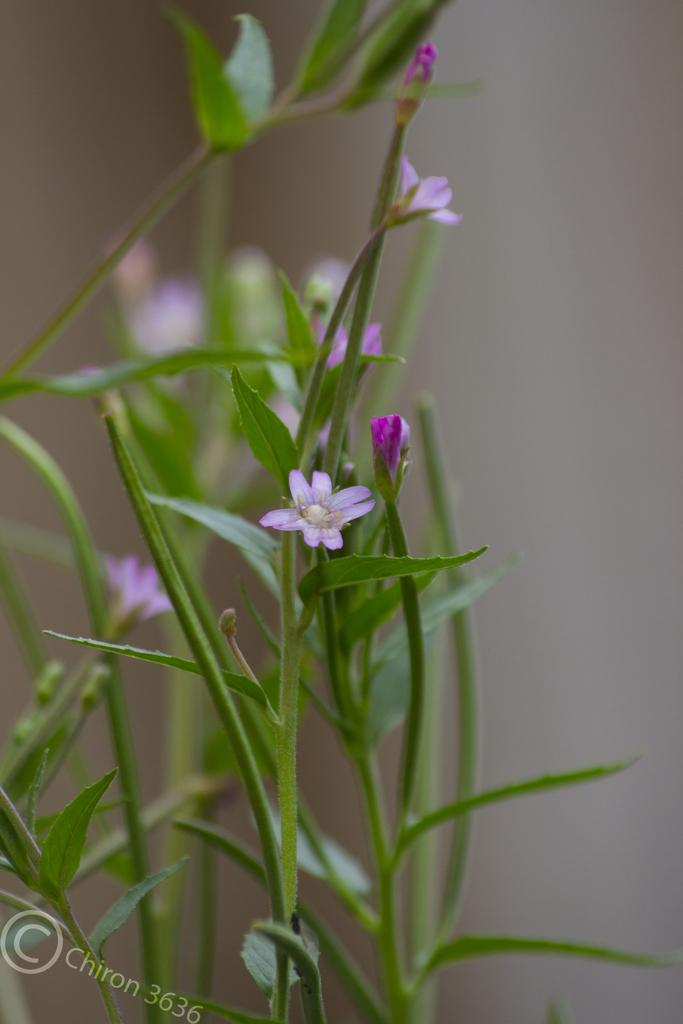What types of living organisms can be seen in the image? The image contains plants and flowers. Can you describe the background of the image? The background of the image is blurred. What color is the crayon used to draw the flowers in the image? There is no crayon present in the image, as the flowers are real and not drawn. How many steps does it take to reach the flowers in the image? There is no indication of distance or location in the image, so it is not possible to determine the number of steps required to reach the flowers. 